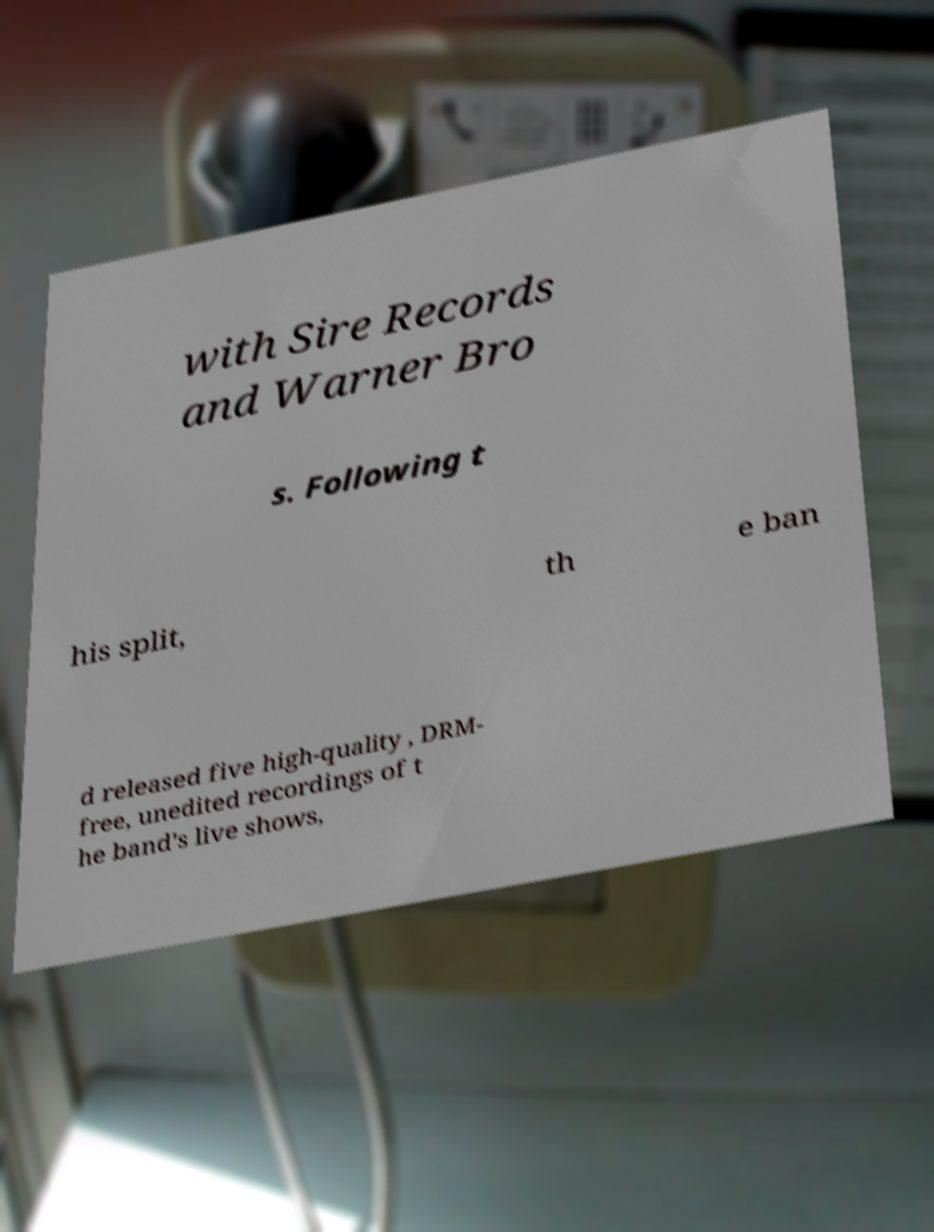Can you accurately transcribe the text from the provided image for me? with Sire Records and Warner Bro s. Following t his split, th e ban d released five high-quality , DRM- free, unedited recordings of t he band's live shows, 